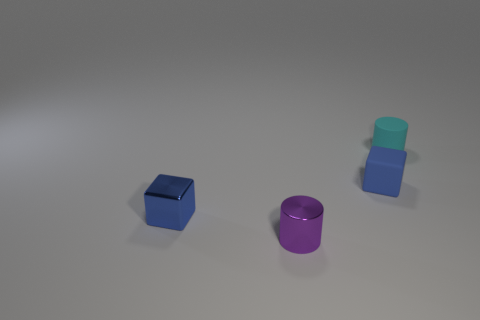Subtract all brown cylinders. Subtract all purple balls. How many cylinders are left? 2 Add 2 tiny yellow things. How many objects exist? 6 Add 2 blue rubber things. How many blue rubber things are left? 3 Add 4 purple metallic things. How many purple metallic things exist? 5 Subtract 0 purple spheres. How many objects are left? 4 Subtract all tiny metal cylinders. Subtract all small green rubber balls. How many objects are left? 3 